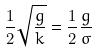<formula> <loc_0><loc_0><loc_500><loc_500>\frac { 1 } { 2 } \sqrt { \frac { g } { k } } = \frac { 1 } { 2 } \frac { g } { \sigma }</formula> 